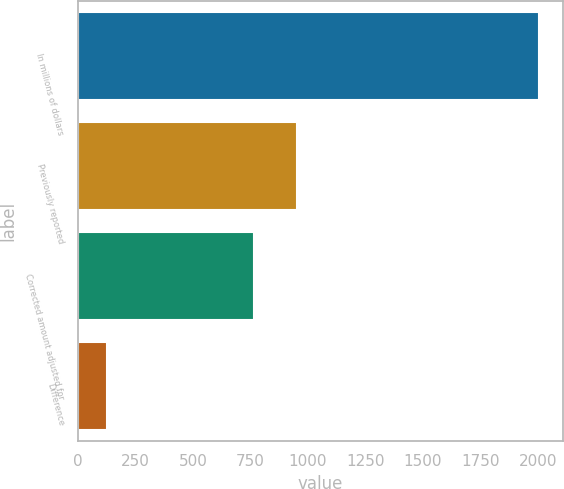Convert chart to OTSL. <chart><loc_0><loc_0><loc_500><loc_500><bar_chart><fcel>In millions of dollars<fcel>Previously reported<fcel>Corrected amount adjusted for<fcel>Difference<nl><fcel>2007<fcel>952.3<fcel>764<fcel>124<nl></chart> 